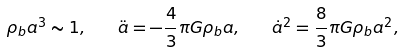<formula> <loc_0><loc_0><loc_500><loc_500>\rho _ { b } a ^ { 3 } \sim 1 , \quad \ddot { a } = - \frac { 4 } { 3 } \pi G \rho _ { b } a , \quad { \dot { a } } ^ { 2 } = \frac { 8 } { 3 } \pi G \rho _ { b } a ^ { 2 } ,</formula> 